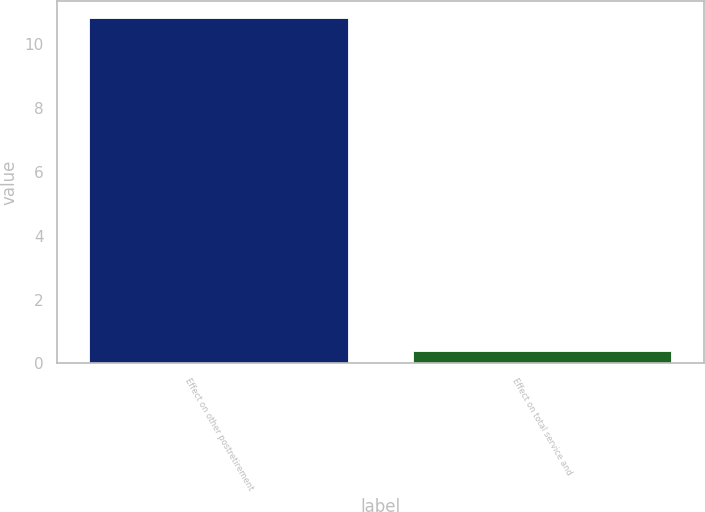Convert chart. <chart><loc_0><loc_0><loc_500><loc_500><bar_chart><fcel>Effect on other postretirement<fcel>Effect on total service and<nl><fcel>10.8<fcel>0.4<nl></chart> 